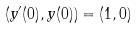<formula> <loc_0><loc_0><loc_500><loc_500>( y ^ { \prime } ( 0 ) , y ( 0 ) ) = ( 1 , 0 )</formula> 